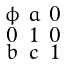<formula> <loc_0><loc_0><loc_500><loc_500>\begin{smallmatrix} \phi & a & 0 \\ 0 & 1 & 0 \\ b & c & 1 \end{smallmatrix}</formula> 